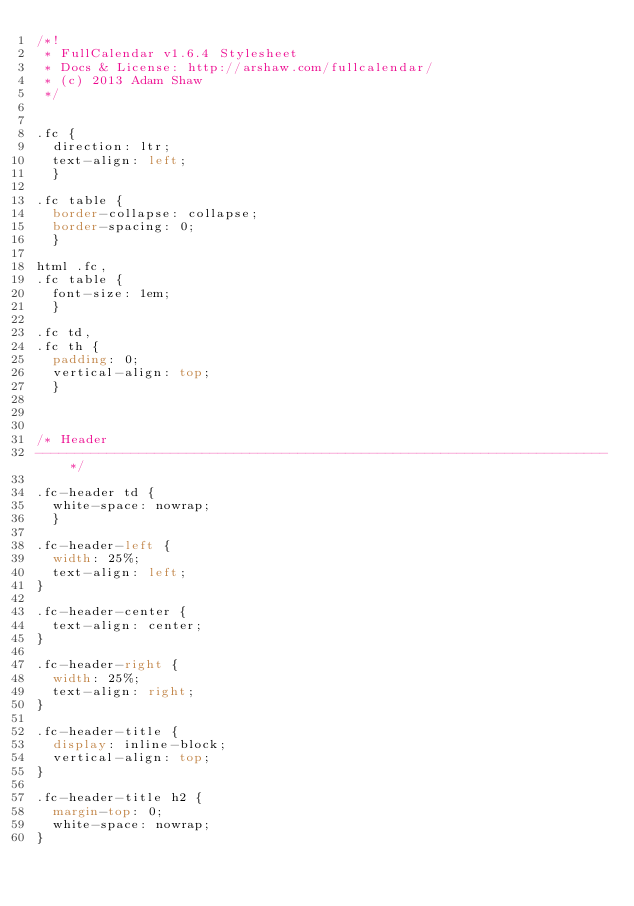<code> <loc_0><loc_0><loc_500><loc_500><_CSS_>/*!
 * FullCalendar v1.6.4 Stylesheet
 * Docs & License: http://arshaw.com/fullcalendar/
 * (c) 2013 Adam Shaw
 */


.fc {
	direction: ltr;
	text-align: left;
	}
	
.fc table {
	border-collapse: collapse;
	border-spacing: 0;
	}
	
html .fc,
.fc table {
	font-size: 1em;
	}
	
.fc td,
.fc th {
	padding: 0;
	vertical-align: top;
	}



/* Header
------------------------------------------------------------------------*/

.fc-header td {
	white-space: nowrap;
	}

.fc-header-left {
	width: 25%;
	text-align: left;
}
	
.fc-header-center {
	text-align: center;
}
	
.fc-header-right {
	width: 25%;
	text-align: right;
}
	
.fc-header-title {
	display: inline-block;
	vertical-align: top;
}
	
.fc-header-title h2 {
	margin-top: 0;
	white-space: nowrap;
}
	</code> 